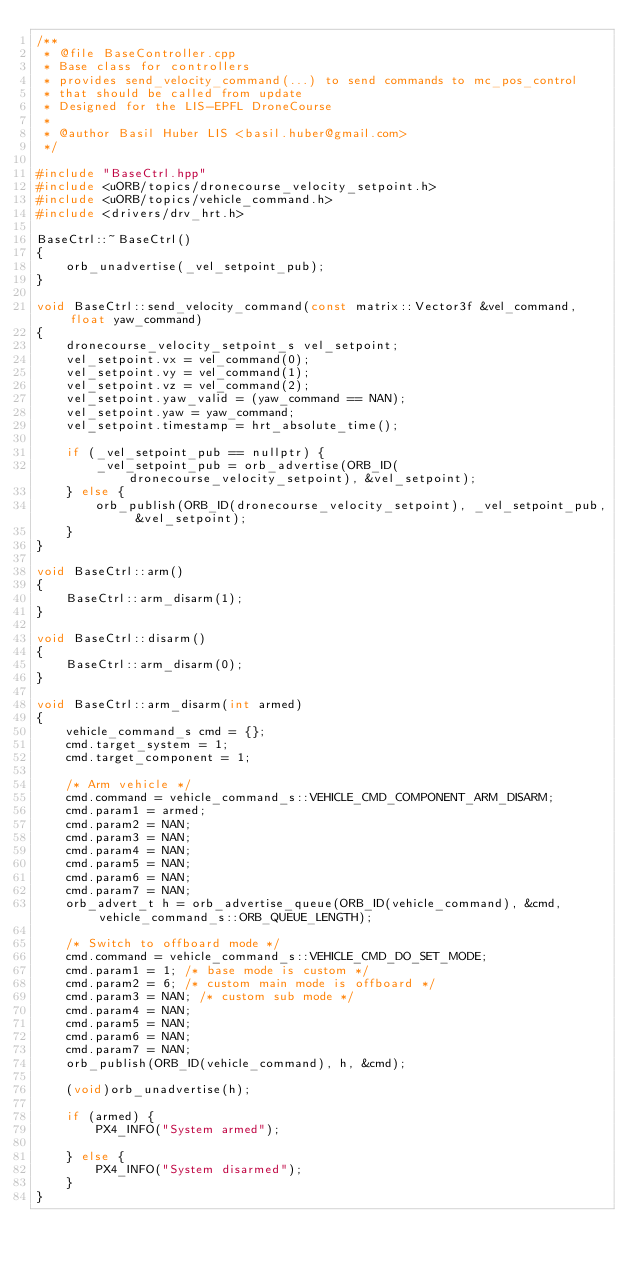Convert code to text. <code><loc_0><loc_0><loc_500><loc_500><_C++_>/**
 * @file BaseController.cpp
 * Base class for controllers
 * provides send_velocity_command(...) to send commands to mc_pos_control
 * that should be called from update
 * Designed for the LIS-EPFL DroneCourse
 *
 * @author Basil Huber LIS <basil.huber@gmail.com>
 */

#include "BaseCtrl.hpp"
#include <uORB/topics/dronecourse_velocity_setpoint.h>
#include <uORB/topics/vehicle_command.h>
#include <drivers/drv_hrt.h>

BaseCtrl::~BaseCtrl()
{
	orb_unadvertise(_vel_setpoint_pub);
}

void BaseCtrl::send_velocity_command(const matrix::Vector3f &vel_command, float yaw_command)
{
	dronecourse_velocity_setpoint_s vel_setpoint;
	vel_setpoint.vx = vel_command(0);
	vel_setpoint.vy = vel_command(1);
	vel_setpoint.vz = vel_command(2);
	vel_setpoint.yaw_valid = (yaw_command == NAN);
	vel_setpoint.yaw = yaw_command;
	vel_setpoint.timestamp = hrt_absolute_time();

	if (_vel_setpoint_pub == nullptr) {
		_vel_setpoint_pub = orb_advertise(ORB_ID(dronecourse_velocity_setpoint), &vel_setpoint);
	} else {
		orb_publish(ORB_ID(dronecourse_velocity_setpoint), _vel_setpoint_pub, &vel_setpoint);
	}
}

void BaseCtrl::arm()
{
	BaseCtrl::arm_disarm(1);
}

void BaseCtrl::disarm()
{
	BaseCtrl::arm_disarm(0);
}

void BaseCtrl::arm_disarm(int armed)
{
	vehicle_command_s cmd = {};
	cmd.target_system = 1;
	cmd.target_component = 1;

	/* Arm vehicle */
	cmd.command = vehicle_command_s::VEHICLE_CMD_COMPONENT_ARM_DISARM;
	cmd.param1 = armed;
	cmd.param2 = NAN;
	cmd.param3 = NAN;
	cmd.param4 = NAN;
	cmd.param5 = NAN;
	cmd.param6 = NAN;
	cmd.param7 = NAN;
	orb_advert_t h = orb_advertise_queue(ORB_ID(vehicle_command), &cmd, vehicle_command_s::ORB_QUEUE_LENGTH);

	/* Switch to offboard mode */
	cmd.command = vehicle_command_s::VEHICLE_CMD_DO_SET_MODE;
	cmd.param1 = 1; /* base mode is custom */
	cmd.param2 = 6; /* custom main mode is offboard */
	cmd.param3 = NAN; /* custom sub mode */
	cmd.param4 = NAN;
	cmd.param5 = NAN;
	cmd.param6 = NAN;
	cmd.param7 = NAN;
	orb_publish(ORB_ID(vehicle_command), h, &cmd);

	(void)orb_unadvertise(h);

	if (armed) {
		PX4_INFO("System armed");

	} else {
		PX4_INFO("System disarmed");
	}
}
</code> 